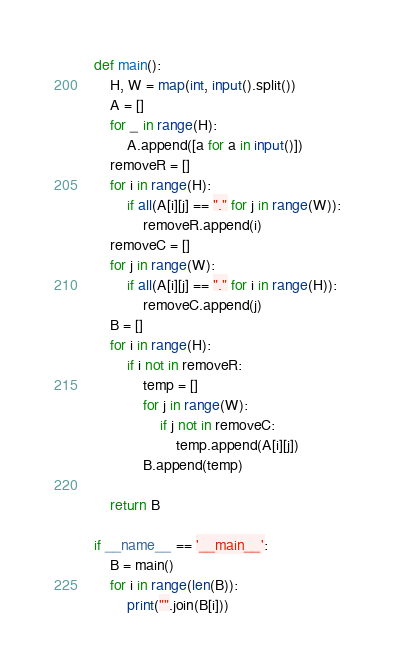<code> <loc_0><loc_0><loc_500><loc_500><_Python_>def main():
    H, W = map(int, input().split())
    A = []
    for _ in range(H):
        A.append([a for a in input()])
    removeR = []
    for i in range(H):
        if all(A[i][j] == "." for j in range(W)):
            removeR.append(i)
    removeC = []
    for j in range(W):
        if all(A[i][j] == "." for i in range(H)):
            removeC.append(j)
    B = []
    for i in range(H):
        if i not in removeR:
            temp = []
            for j in range(W):
                if j not in removeC:
                    temp.append(A[i][j])
            B.append(temp)

    return B

if __name__ == '__main__':
    B = main()
    for i in range(len(B)):
        print("".join(B[i]))</code> 